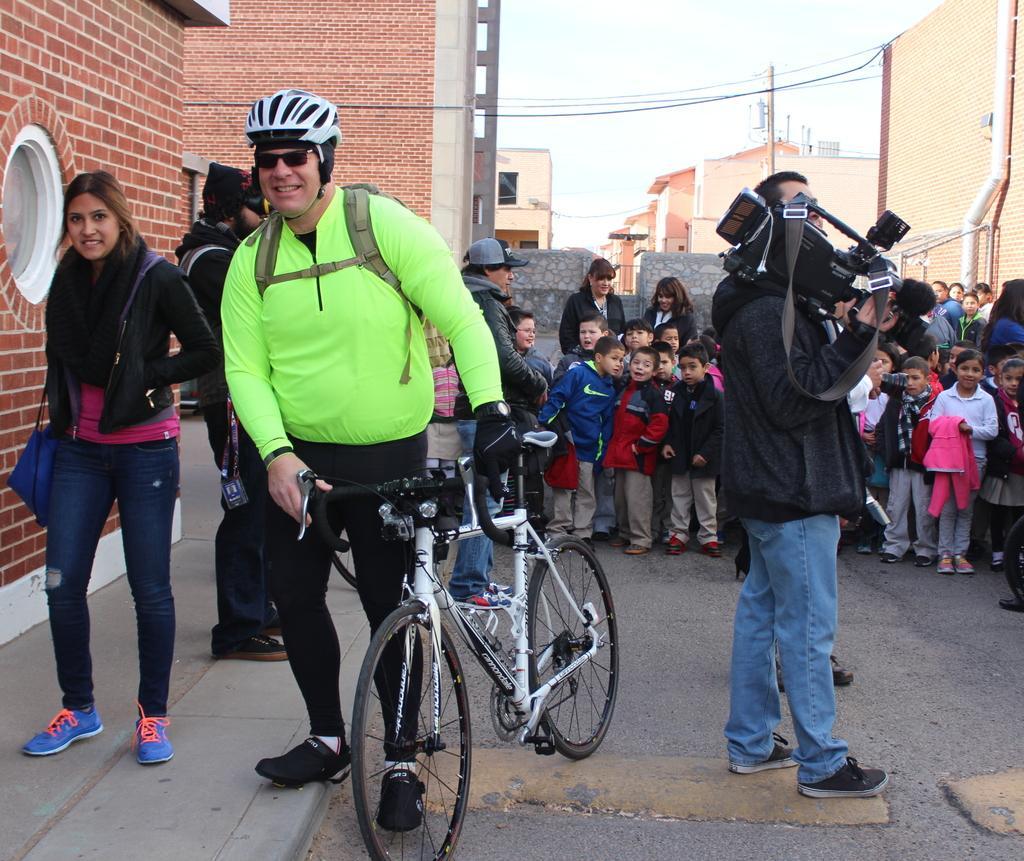Please provide a concise description of this image. In this image there are group of person standing. In the center there is a man holding a bicycle and smiling and there is a woman standing and smiling. On the left side there is a man standing and holding a camera in his hand. In the background there are persons standing and there are buildings, wired and there is a pole. On the right side there is a pipe. 